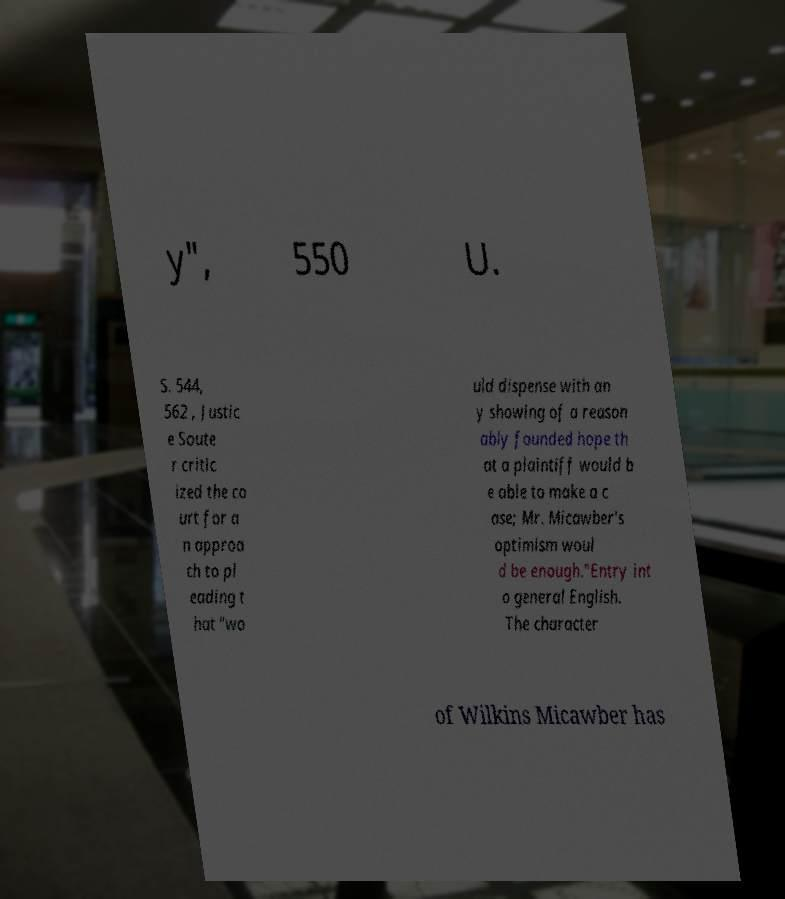For documentation purposes, I need the text within this image transcribed. Could you provide that? y", 550 U. S. 544, 562 , Justic e Soute r critic ized the co urt for a n approa ch to pl eading t hat "wo uld dispense with an y showing of a reason ably founded hope th at a plaintiff would b e able to make a c ase; Mr. Micawber's optimism woul d be enough."Entry int o general English. The character of Wilkins Micawber has 